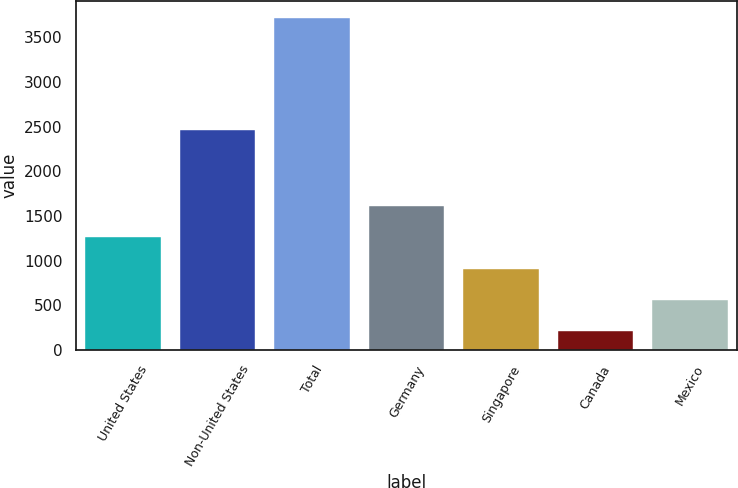Convert chart. <chart><loc_0><loc_0><loc_500><loc_500><bar_chart><fcel>United States<fcel>Non-United States<fcel>Total<fcel>Germany<fcel>Singapore<fcel>Canada<fcel>Mexico<nl><fcel>1263.1<fcel>2466<fcel>3718<fcel>1613.8<fcel>912.4<fcel>211<fcel>561.7<nl></chart> 